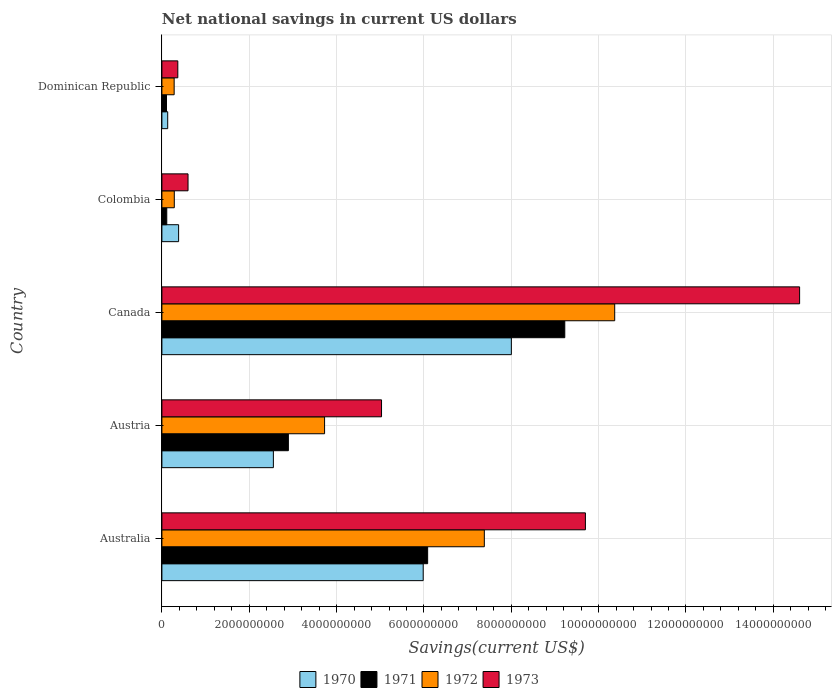How many different coloured bars are there?
Provide a short and direct response. 4. How many groups of bars are there?
Offer a very short reply. 5. Are the number of bars on each tick of the Y-axis equal?
Make the answer very short. Yes. How many bars are there on the 1st tick from the bottom?
Make the answer very short. 4. What is the net national savings in 1970 in Colombia?
Provide a short and direct response. 3.83e+08. Across all countries, what is the maximum net national savings in 1971?
Offer a terse response. 9.23e+09. Across all countries, what is the minimum net national savings in 1972?
Keep it short and to the point. 2.80e+08. In which country was the net national savings in 1971 minimum?
Your answer should be compact. Dominican Republic. What is the total net national savings in 1971 in the graph?
Offer a very short reply. 1.84e+1. What is the difference between the net national savings in 1971 in Austria and that in Dominican Republic?
Your response must be concise. 2.79e+09. What is the difference between the net national savings in 1970 in Australia and the net national savings in 1972 in Austria?
Give a very brief answer. 2.26e+09. What is the average net national savings in 1972 per country?
Keep it short and to the point. 4.41e+09. What is the difference between the net national savings in 1973 and net national savings in 1971 in Dominican Republic?
Offer a very short reply. 2.59e+08. In how many countries, is the net national savings in 1970 greater than 10000000000 US$?
Ensure brevity in your answer.  0. What is the ratio of the net national savings in 1973 in Canada to that in Dominican Republic?
Your answer should be compact. 40.06. Is the difference between the net national savings in 1973 in Austria and Canada greater than the difference between the net national savings in 1971 in Austria and Canada?
Provide a short and direct response. No. What is the difference between the highest and the second highest net national savings in 1970?
Give a very brief answer. 2.02e+09. What is the difference between the highest and the lowest net national savings in 1972?
Provide a short and direct response. 1.01e+1. Is the sum of the net national savings in 1972 in Colombia and Dominican Republic greater than the maximum net national savings in 1973 across all countries?
Your answer should be compact. No. Is it the case that in every country, the sum of the net national savings in 1973 and net national savings in 1971 is greater than the sum of net national savings in 1972 and net national savings in 1970?
Offer a terse response. No. What does the 3rd bar from the bottom in Colombia represents?
Provide a short and direct response. 1972. How many bars are there?
Give a very brief answer. 20. Are all the bars in the graph horizontal?
Provide a succinct answer. Yes. What is the difference between two consecutive major ticks on the X-axis?
Offer a terse response. 2.00e+09. Are the values on the major ticks of X-axis written in scientific E-notation?
Keep it short and to the point. No. Does the graph contain grids?
Ensure brevity in your answer.  Yes. Where does the legend appear in the graph?
Provide a succinct answer. Bottom center. How are the legend labels stacked?
Provide a short and direct response. Horizontal. What is the title of the graph?
Provide a short and direct response. Net national savings in current US dollars. What is the label or title of the X-axis?
Provide a succinct answer. Savings(current US$). What is the Savings(current US$) in 1970 in Australia?
Make the answer very short. 5.98e+09. What is the Savings(current US$) of 1971 in Australia?
Your answer should be compact. 6.09e+09. What is the Savings(current US$) of 1972 in Australia?
Your answer should be compact. 7.38e+09. What is the Savings(current US$) of 1973 in Australia?
Make the answer very short. 9.70e+09. What is the Savings(current US$) of 1970 in Austria?
Keep it short and to the point. 2.55e+09. What is the Savings(current US$) in 1971 in Austria?
Provide a short and direct response. 2.90e+09. What is the Savings(current US$) in 1972 in Austria?
Your answer should be very brief. 3.73e+09. What is the Savings(current US$) in 1973 in Austria?
Offer a very short reply. 5.03e+09. What is the Savings(current US$) of 1970 in Canada?
Your answer should be very brief. 8.00e+09. What is the Savings(current US$) of 1971 in Canada?
Make the answer very short. 9.23e+09. What is the Savings(current US$) in 1972 in Canada?
Your response must be concise. 1.04e+1. What is the Savings(current US$) of 1973 in Canada?
Offer a terse response. 1.46e+1. What is the Savings(current US$) in 1970 in Colombia?
Your answer should be compact. 3.83e+08. What is the Savings(current US$) in 1971 in Colombia?
Your answer should be compact. 1.11e+08. What is the Savings(current US$) in 1972 in Colombia?
Ensure brevity in your answer.  2.84e+08. What is the Savings(current US$) in 1973 in Colombia?
Offer a very short reply. 5.98e+08. What is the Savings(current US$) of 1970 in Dominican Republic?
Your answer should be very brief. 1.33e+08. What is the Savings(current US$) in 1971 in Dominican Republic?
Provide a short and direct response. 1.05e+08. What is the Savings(current US$) in 1972 in Dominican Republic?
Keep it short and to the point. 2.80e+08. What is the Savings(current US$) in 1973 in Dominican Republic?
Provide a succinct answer. 3.65e+08. Across all countries, what is the maximum Savings(current US$) of 1970?
Your answer should be very brief. 8.00e+09. Across all countries, what is the maximum Savings(current US$) of 1971?
Your answer should be compact. 9.23e+09. Across all countries, what is the maximum Savings(current US$) in 1972?
Offer a terse response. 1.04e+1. Across all countries, what is the maximum Savings(current US$) in 1973?
Keep it short and to the point. 1.46e+1. Across all countries, what is the minimum Savings(current US$) of 1970?
Give a very brief answer. 1.33e+08. Across all countries, what is the minimum Savings(current US$) of 1971?
Provide a short and direct response. 1.05e+08. Across all countries, what is the minimum Savings(current US$) of 1972?
Make the answer very short. 2.80e+08. Across all countries, what is the minimum Savings(current US$) in 1973?
Your answer should be very brief. 3.65e+08. What is the total Savings(current US$) of 1970 in the graph?
Make the answer very short. 1.71e+1. What is the total Savings(current US$) of 1971 in the graph?
Provide a succinct answer. 1.84e+1. What is the total Savings(current US$) of 1972 in the graph?
Your answer should be compact. 2.20e+1. What is the total Savings(current US$) of 1973 in the graph?
Provide a short and direct response. 3.03e+1. What is the difference between the Savings(current US$) of 1970 in Australia and that in Austria?
Offer a terse response. 3.43e+09. What is the difference between the Savings(current US$) of 1971 in Australia and that in Austria?
Ensure brevity in your answer.  3.19e+09. What is the difference between the Savings(current US$) in 1972 in Australia and that in Austria?
Offer a very short reply. 3.66e+09. What is the difference between the Savings(current US$) of 1973 in Australia and that in Austria?
Your answer should be very brief. 4.67e+09. What is the difference between the Savings(current US$) of 1970 in Australia and that in Canada?
Your answer should be very brief. -2.02e+09. What is the difference between the Savings(current US$) in 1971 in Australia and that in Canada?
Make the answer very short. -3.14e+09. What is the difference between the Savings(current US$) in 1972 in Australia and that in Canada?
Give a very brief answer. -2.99e+09. What is the difference between the Savings(current US$) in 1973 in Australia and that in Canada?
Give a very brief answer. -4.90e+09. What is the difference between the Savings(current US$) in 1970 in Australia and that in Colombia?
Offer a very short reply. 5.60e+09. What is the difference between the Savings(current US$) in 1971 in Australia and that in Colombia?
Your answer should be compact. 5.97e+09. What is the difference between the Savings(current US$) of 1972 in Australia and that in Colombia?
Your response must be concise. 7.10e+09. What is the difference between the Savings(current US$) in 1973 in Australia and that in Colombia?
Your response must be concise. 9.10e+09. What is the difference between the Savings(current US$) of 1970 in Australia and that in Dominican Republic?
Ensure brevity in your answer.  5.85e+09. What is the difference between the Savings(current US$) of 1971 in Australia and that in Dominican Republic?
Offer a very short reply. 5.98e+09. What is the difference between the Savings(current US$) in 1972 in Australia and that in Dominican Republic?
Your answer should be compact. 7.10e+09. What is the difference between the Savings(current US$) in 1973 in Australia and that in Dominican Republic?
Offer a terse response. 9.33e+09. What is the difference between the Savings(current US$) of 1970 in Austria and that in Canada?
Your response must be concise. -5.45e+09. What is the difference between the Savings(current US$) of 1971 in Austria and that in Canada?
Provide a short and direct response. -6.33e+09. What is the difference between the Savings(current US$) in 1972 in Austria and that in Canada?
Offer a terse response. -6.64e+09. What is the difference between the Savings(current US$) of 1973 in Austria and that in Canada?
Ensure brevity in your answer.  -9.57e+09. What is the difference between the Savings(current US$) of 1970 in Austria and that in Colombia?
Your answer should be compact. 2.17e+09. What is the difference between the Savings(current US$) in 1971 in Austria and that in Colombia?
Provide a succinct answer. 2.78e+09. What is the difference between the Savings(current US$) of 1972 in Austria and that in Colombia?
Offer a terse response. 3.44e+09. What is the difference between the Savings(current US$) of 1973 in Austria and that in Colombia?
Your answer should be compact. 4.43e+09. What is the difference between the Savings(current US$) of 1970 in Austria and that in Dominican Republic?
Your response must be concise. 2.42e+09. What is the difference between the Savings(current US$) of 1971 in Austria and that in Dominican Republic?
Provide a short and direct response. 2.79e+09. What is the difference between the Savings(current US$) of 1972 in Austria and that in Dominican Republic?
Your answer should be very brief. 3.44e+09. What is the difference between the Savings(current US$) of 1973 in Austria and that in Dominican Republic?
Keep it short and to the point. 4.66e+09. What is the difference between the Savings(current US$) in 1970 in Canada and that in Colombia?
Offer a terse response. 7.62e+09. What is the difference between the Savings(current US$) of 1971 in Canada and that in Colombia?
Your response must be concise. 9.11e+09. What is the difference between the Savings(current US$) in 1972 in Canada and that in Colombia?
Offer a very short reply. 1.01e+1. What is the difference between the Savings(current US$) of 1973 in Canada and that in Colombia?
Your answer should be very brief. 1.40e+1. What is the difference between the Savings(current US$) in 1970 in Canada and that in Dominican Republic?
Your answer should be compact. 7.87e+09. What is the difference between the Savings(current US$) in 1971 in Canada and that in Dominican Republic?
Provide a short and direct response. 9.12e+09. What is the difference between the Savings(current US$) of 1972 in Canada and that in Dominican Republic?
Your answer should be very brief. 1.01e+1. What is the difference between the Savings(current US$) in 1973 in Canada and that in Dominican Republic?
Your answer should be compact. 1.42e+1. What is the difference between the Savings(current US$) in 1970 in Colombia and that in Dominican Republic?
Offer a terse response. 2.50e+08. What is the difference between the Savings(current US$) of 1971 in Colombia and that in Dominican Republic?
Your answer should be very brief. 6.03e+06. What is the difference between the Savings(current US$) of 1972 in Colombia and that in Dominican Republic?
Your answer should be very brief. 3.48e+06. What is the difference between the Savings(current US$) in 1973 in Colombia and that in Dominican Republic?
Offer a very short reply. 2.34e+08. What is the difference between the Savings(current US$) of 1970 in Australia and the Savings(current US$) of 1971 in Austria?
Provide a succinct answer. 3.09e+09. What is the difference between the Savings(current US$) in 1970 in Australia and the Savings(current US$) in 1972 in Austria?
Provide a short and direct response. 2.26e+09. What is the difference between the Savings(current US$) of 1970 in Australia and the Savings(current US$) of 1973 in Austria?
Provide a succinct answer. 9.54e+08. What is the difference between the Savings(current US$) of 1971 in Australia and the Savings(current US$) of 1972 in Austria?
Your answer should be compact. 2.36e+09. What is the difference between the Savings(current US$) in 1971 in Australia and the Savings(current US$) in 1973 in Austria?
Ensure brevity in your answer.  1.06e+09. What is the difference between the Savings(current US$) of 1972 in Australia and the Savings(current US$) of 1973 in Austria?
Keep it short and to the point. 2.35e+09. What is the difference between the Savings(current US$) of 1970 in Australia and the Savings(current US$) of 1971 in Canada?
Your response must be concise. -3.24e+09. What is the difference between the Savings(current US$) in 1970 in Australia and the Savings(current US$) in 1972 in Canada?
Keep it short and to the point. -4.38e+09. What is the difference between the Savings(current US$) of 1970 in Australia and the Savings(current US$) of 1973 in Canada?
Provide a succinct answer. -8.62e+09. What is the difference between the Savings(current US$) of 1971 in Australia and the Savings(current US$) of 1972 in Canada?
Your response must be concise. -4.28e+09. What is the difference between the Savings(current US$) in 1971 in Australia and the Savings(current US$) in 1973 in Canada?
Provide a succinct answer. -8.52e+09. What is the difference between the Savings(current US$) in 1972 in Australia and the Savings(current US$) in 1973 in Canada?
Provide a succinct answer. -7.22e+09. What is the difference between the Savings(current US$) of 1970 in Australia and the Savings(current US$) of 1971 in Colombia?
Give a very brief answer. 5.87e+09. What is the difference between the Savings(current US$) in 1970 in Australia and the Savings(current US$) in 1972 in Colombia?
Your response must be concise. 5.70e+09. What is the difference between the Savings(current US$) of 1970 in Australia and the Savings(current US$) of 1973 in Colombia?
Keep it short and to the point. 5.38e+09. What is the difference between the Savings(current US$) of 1971 in Australia and the Savings(current US$) of 1972 in Colombia?
Provide a succinct answer. 5.80e+09. What is the difference between the Savings(current US$) of 1971 in Australia and the Savings(current US$) of 1973 in Colombia?
Offer a very short reply. 5.49e+09. What is the difference between the Savings(current US$) in 1972 in Australia and the Savings(current US$) in 1973 in Colombia?
Make the answer very short. 6.78e+09. What is the difference between the Savings(current US$) in 1970 in Australia and the Savings(current US$) in 1971 in Dominican Republic?
Provide a succinct answer. 5.88e+09. What is the difference between the Savings(current US$) in 1970 in Australia and the Savings(current US$) in 1972 in Dominican Republic?
Ensure brevity in your answer.  5.70e+09. What is the difference between the Savings(current US$) of 1970 in Australia and the Savings(current US$) of 1973 in Dominican Republic?
Offer a very short reply. 5.62e+09. What is the difference between the Savings(current US$) of 1971 in Australia and the Savings(current US$) of 1972 in Dominican Republic?
Provide a succinct answer. 5.80e+09. What is the difference between the Savings(current US$) in 1971 in Australia and the Savings(current US$) in 1973 in Dominican Republic?
Give a very brief answer. 5.72e+09. What is the difference between the Savings(current US$) in 1972 in Australia and the Savings(current US$) in 1973 in Dominican Republic?
Ensure brevity in your answer.  7.02e+09. What is the difference between the Savings(current US$) in 1970 in Austria and the Savings(current US$) in 1971 in Canada?
Ensure brevity in your answer.  -6.67e+09. What is the difference between the Savings(current US$) of 1970 in Austria and the Savings(current US$) of 1972 in Canada?
Make the answer very short. -7.82e+09. What is the difference between the Savings(current US$) in 1970 in Austria and the Savings(current US$) in 1973 in Canada?
Your answer should be very brief. -1.20e+1. What is the difference between the Savings(current US$) of 1971 in Austria and the Savings(current US$) of 1972 in Canada?
Your answer should be compact. -7.47e+09. What is the difference between the Savings(current US$) in 1971 in Austria and the Savings(current US$) in 1973 in Canada?
Your answer should be very brief. -1.17e+1. What is the difference between the Savings(current US$) of 1972 in Austria and the Savings(current US$) of 1973 in Canada?
Your response must be concise. -1.09e+1. What is the difference between the Savings(current US$) of 1970 in Austria and the Savings(current US$) of 1971 in Colombia?
Give a very brief answer. 2.44e+09. What is the difference between the Savings(current US$) in 1970 in Austria and the Savings(current US$) in 1972 in Colombia?
Ensure brevity in your answer.  2.27e+09. What is the difference between the Savings(current US$) of 1970 in Austria and the Savings(current US$) of 1973 in Colombia?
Provide a succinct answer. 1.95e+09. What is the difference between the Savings(current US$) of 1971 in Austria and the Savings(current US$) of 1972 in Colombia?
Your response must be concise. 2.61e+09. What is the difference between the Savings(current US$) in 1971 in Austria and the Savings(current US$) in 1973 in Colombia?
Your response must be concise. 2.30e+09. What is the difference between the Savings(current US$) in 1972 in Austria and the Savings(current US$) in 1973 in Colombia?
Offer a very short reply. 3.13e+09. What is the difference between the Savings(current US$) in 1970 in Austria and the Savings(current US$) in 1971 in Dominican Republic?
Ensure brevity in your answer.  2.45e+09. What is the difference between the Savings(current US$) in 1970 in Austria and the Savings(current US$) in 1972 in Dominican Republic?
Your answer should be compact. 2.27e+09. What is the difference between the Savings(current US$) in 1970 in Austria and the Savings(current US$) in 1973 in Dominican Republic?
Provide a short and direct response. 2.19e+09. What is the difference between the Savings(current US$) in 1971 in Austria and the Savings(current US$) in 1972 in Dominican Republic?
Provide a succinct answer. 2.62e+09. What is the difference between the Savings(current US$) of 1971 in Austria and the Savings(current US$) of 1973 in Dominican Republic?
Provide a succinct answer. 2.53e+09. What is the difference between the Savings(current US$) in 1972 in Austria and the Savings(current US$) in 1973 in Dominican Republic?
Provide a succinct answer. 3.36e+09. What is the difference between the Savings(current US$) of 1970 in Canada and the Savings(current US$) of 1971 in Colombia?
Offer a very short reply. 7.89e+09. What is the difference between the Savings(current US$) of 1970 in Canada and the Savings(current US$) of 1972 in Colombia?
Give a very brief answer. 7.72e+09. What is the difference between the Savings(current US$) of 1970 in Canada and the Savings(current US$) of 1973 in Colombia?
Make the answer very short. 7.40e+09. What is the difference between the Savings(current US$) of 1971 in Canada and the Savings(current US$) of 1972 in Colombia?
Your answer should be compact. 8.94e+09. What is the difference between the Savings(current US$) of 1971 in Canada and the Savings(current US$) of 1973 in Colombia?
Your response must be concise. 8.63e+09. What is the difference between the Savings(current US$) in 1972 in Canada and the Savings(current US$) in 1973 in Colombia?
Make the answer very short. 9.77e+09. What is the difference between the Savings(current US$) of 1970 in Canada and the Savings(current US$) of 1971 in Dominican Republic?
Your response must be concise. 7.90e+09. What is the difference between the Savings(current US$) of 1970 in Canada and the Savings(current US$) of 1972 in Dominican Republic?
Provide a succinct answer. 7.72e+09. What is the difference between the Savings(current US$) of 1970 in Canada and the Savings(current US$) of 1973 in Dominican Republic?
Your answer should be compact. 7.64e+09. What is the difference between the Savings(current US$) in 1971 in Canada and the Savings(current US$) in 1972 in Dominican Republic?
Provide a short and direct response. 8.94e+09. What is the difference between the Savings(current US$) of 1971 in Canada and the Savings(current US$) of 1973 in Dominican Republic?
Give a very brief answer. 8.86e+09. What is the difference between the Savings(current US$) in 1972 in Canada and the Savings(current US$) in 1973 in Dominican Republic?
Provide a succinct answer. 1.00e+1. What is the difference between the Savings(current US$) in 1970 in Colombia and the Savings(current US$) in 1971 in Dominican Republic?
Give a very brief answer. 2.77e+08. What is the difference between the Savings(current US$) of 1970 in Colombia and the Savings(current US$) of 1972 in Dominican Republic?
Keep it short and to the point. 1.02e+08. What is the difference between the Savings(current US$) of 1970 in Colombia and the Savings(current US$) of 1973 in Dominican Republic?
Ensure brevity in your answer.  1.82e+07. What is the difference between the Savings(current US$) of 1971 in Colombia and the Savings(current US$) of 1972 in Dominican Republic?
Your response must be concise. -1.69e+08. What is the difference between the Savings(current US$) of 1971 in Colombia and the Savings(current US$) of 1973 in Dominican Republic?
Your response must be concise. -2.53e+08. What is the difference between the Savings(current US$) in 1972 in Colombia and the Savings(current US$) in 1973 in Dominican Republic?
Offer a terse response. -8.05e+07. What is the average Savings(current US$) in 1970 per country?
Ensure brevity in your answer.  3.41e+09. What is the average Savings(current US$) of 1971 per country?
Keep it short and to the point. 3.68e+09. What is the average Savings(current US$) in 1972 per country?
Your response must be concise. 4.41e+09. What is the average Savings(current US$) in 1973 per country?
Keep it short and to the point. 6.06e+09. What is the difference between the Savings(current US$) in 1970 and Savings(current US$) in 1971 in Australia?
Ensure brevity in your answer.  -1.02e+08. What is the difference between the Savings(current US$) in 1970 and Savings(current US$) in 1972 in Australia?
Your answer should be very brief. -1.40e+09. What is the difference between the Savings(current US$) of 1970 and Savings(current US$) of 1973 in Australia?
Offer a terse response. -3.71e+09. What is the difference between the Savings(current US$) of 1971 and Savings(current US$) of 1972 in Australia?
Your response must be concise. -1.30e+09. What is the difference between the Savings(current US$) of 1971 and Savings(current US$) of 1973 in Australia?
Offer a very short reply. -3.61e+09. What is the difference between the Savings(current US$) of 1972 and Savings(current US$) of 1973 in Australia?
Ensure brevity in your answer.  -2.31e+09. What is the difference between the Savings(current US$) of 1970 and Savings(current US$) of 1971 in Austria?
Your answer should be compact. -3.44e+08. What is the difference between the Savings(current US$) of 1970 and Savings(current US$) of 1972 in Austria?
Keep it short and to the point. -1.17e+09. What is the difference between the Savings(current US$) in 1970 and Savings(current US$) in 1973 in Austria?
Offer a terse response. -2.48e+09. What is the difference between the Savings(current US$) of 1971 and Savings(current US$) of 1972 in Austria?
Your answer should be very brief. -8.29e+08. What is the difference between the Savings(current US$) in 1971 and Savings(current US$) in 1973 in Austria?
Your answer should be compact. -2.13e+09. What is the difference between the Savings(current US$) of 1972 and Savings(current US$) of 1973 in Austria?
Your response must be concise. -1.30e+09. What is the difference between the Savings(current US$) of 1970 and Savings(current US$) of 1971 in Canada?
Provide a succinct answer. -1.22e+09. What is the difference between the Savings(current US$) of 1970 and Savings(current US$) of 1972 in Canada?
Ensure brevity in your answer.  -2.37e+09. What is the difference between the Savings(current US$) of 1970 and Savings(current US$) of 1973 in Canada?
Provide a short and direct response. -6.60e+09. What is the difference between the Savings(current US$) in 1971 and Savings(current US$) in 1972 in Canada?
Your answer should be compact. -1.14e+09. What is the difference between the Savings(current US$) of 1971 and Savings(current US$) of 1973 in Canada?
Offer a terse response. -5.38e+09. What is the difference between the Savings(current US$) in 1972 and Savings(current US$) in 1973 in Canada?
Your answer should be very brief. -4.23e+09. What is the difference between the Savings(current US$) in 1970 and Savings(current US$) in 1971 in Colombia?
Provide a succinct answer. 2.71e+08. What is the difference between the Savings(current US$) of 1970 and Savings(current US$) of 1972 in Colombia?
Your response must be concise. 9.87e+07. What is the difference between the Savings(current US$) in 1970 and Savings(current US$) in 1973 in Colombia?
Offer a very short reply. -2.16e+08. What is the difference between the Savings(current US$) of 1971 and Savings(current US$) of 1972 in Colombia?
Keep it short and to the point. -1.73e+08. What is the difference between the Savings(current US$) of 1971 and Savings(current US$) of 1973 in Colombia?
Your response must be concise. -4.87e+08. What is the difference between the Savings(current US$) of 1972 and Savings(current US$) of 1973 in Colombia?
Make the answer very short. -3.14e+08. What is the difference between the Savings(current US$) in 1970 and Savings(current US$) in 1971 in Dominican Republic?
Keep it short and to the point. 2.74e+07. What is the difference between the Savings(current US$) of 1970 and Savings(current US$) of 1972 in Dominican Republic?
Offer a terse response. -1.48e+08. What is the difference between the Savings(current US$) in 1970 and Savings(current US$) in 1973 in Dominican Republic?
Provide a succinct answer. -2.32e+08. What is the difference between the Savings(current US$) in 1971 and Savings(current US$) in 1972 in Dominican Republic?
Provide a short and direct response. -1.75e+08. What is the difference between the Savings(current US$) of 1971 and Savings(current US$) of 1973 in Dominican Republic?
Your response must be concise. -2.59e+08. What is the difference between the Savings(current US$) in 1972 and Savings(current US$) in 1973 in Dominican Republic?
Keep it short and to the point. -8.40e+07. What is the ratio of the Savings(current US$) in 1970 in Australia to that in Austria?
Keep it short and to the point. 2.34. What is the ratio of the Savings(current US$) in 1971 in Australia to that in Austria?
Provide a short and direct response. 2.1. What is the ratio of the Savings(current US$) of 1972 in Australia to that in Austria?
Your answer should be very brief. 1.98. What is the ratio of the Savings(current US$) of 1973 in Australia to that in Austria?
Provide a succinct answer. 1.93. What is the ratio of the Savings(current US$) of 1970 in Australia to that in Canada?
Offer a very short reply. 0.75. What is the ratio of the Savings(current US$) in 1971 in Australia to that in Canada?
Offer a very short reply. 0.66. What is the ratio of the Savings(current US$) of 1972 in Australia to that in Canada?
Ensure brevity in your answer.  0.71. What is the ratio of the Savings(current US$) in 1973 in Australia to that in Canada?
Make the answer very short. 0.66. What is the ratio of the Savings(current US$) in 1970 in Australia to that in Colombia?
Your answer should be compact. 15.64. What is the ratio of the Savings(current US$) of 1971 in Australia to that in Colombia?
Your response must be concise. 54.61. What is the ratio of the Savings(current US$) of 1972 in Australia to that in Colombia?
Your response must be concise. 26. What is the ratio of the Savings(current US$) in 1973 in Australia to that in Colombia?
Offer a very short reply. 16.2. What is the ratio of the Savings(current US$) in 1970 in Australia to that in Dominican Republic?
Keep it short and to the point. 45.07. What is the ratio of the Savings(current US$) of 1971 in Australia to that in Dominican Republic?
Keep it short and to the point. 57.73. What is the ratio of the Savings(current US$) of 1972 in Australia to that in Dominican Republic?
Make the answer very short. 26.32. What is the ratio of the Savings(current US$) in 1973 in Australia to that in Dominican Republic?
Ensure brevity in your answer.  26.6. What is the ratio of the Savings(current US$) in 1970 in Austria to that in Canada?
Offer a very short reply. 0.32. What is the ratio of the Savings(current US$) in 1971 in Austria to that in Canada?
Keep it short and to the point. 0.31. What is the ratio of the Savings(current US$) in 1972 in Austria to that in Canada?
Keep it short and to the point. 0.36. What is the ratio of the Savings(current US$) of 1973 in Austria to that in Canada?
Your answer should be compact. 0.34. What is the ratio of the Savings(current US$) in 1970 in Austria to that in Colombia?
Your answer should be very brief. 6.67. What is the ratio of the Savings(current US$) of 1971 in Austria to that in Colombia?
Keep it short and to the point. 25.99. What is the ratio of the Savings(current US$) in 1972 in Austria to that in Colombia?
Give a very brief answer. 13.12. What is the ratio of the Savings(current US$) of 1973 in Austria to that in Colombia?
Provide a short and direct response. 8.4. What is the ratio of the Savings(current US$) of 1970 in Austria to that in Dominican Republic?
Offer a very short reply. 19.23. What is the ratio of the Savings(current US$) of 1971 in Austria to that in Dominican Republic?
Your answer should be very brief. 27.48. What is the ratio of the Savings(current US$) in 1972 in Austria to that in Dominican Republic?
Provide a short and direct response. 13.28. What is the ratio of the Savings(current US$) of 1973 in Austria to that in Dominican Republic?
Your answer should be very brief. 13.8. What is the ratio of the Savings(current US$) of 1970 in Canada to that in Colombia?
Provide a succinct answer. 20.91. What is the ratio of the Savings(current US$) in 1971 in Canada to that in Colombia?
Provide a succinct answer. 82.79. What is the ratio of the Savings(current US$) of 1972 in Canada to that in Colombia?
Offer a very short reply. 36.51. What is the ratio of the Savings(current US$) in 1973 in Canada to that in Colombia?
Your answer should be compact. 24.4. What is the ratio of the Savings(current US$) of 1970 in Canada to that in Dominican Republic?
Your answer should be very brief. 60.27. What is the ratio of the Savings(current US$) of 1971 in Canada to that in Dominican Republic?
Offer a very short reply. 87.52. What is the ratio of the Savings(current US$) of 1972 in Canada to that in Dominican Republic?
Offer a very short reply. 36.96. What is the ratio of the Savings(current US$) in 1973 in Canada to that in Dominican Republic?
Your response must be concise. 40.06. What is the ratio of the Savings(current US$) of 1970 in Colombia to that in Dominican Republic?
Offer a very short reply. 2.88. What is the ratio of the Savings(current US$) in 1971 in Colombia to that in Dominican Republic?
Your answer should be very brief. 1.06. What is the ratio of the Savings(current US$) of 1972 in Colombia to that in Dominican Republic?
Your answer should be very brief. 1.01. What is the ratio of the Savings(current US$) in 1973 in Colombia to that in Dominican Republic?
Your response must be concise. 1.64. What is the difference between the highest and the second highest Savings(current US$) of 1970?
Offer a very short reply. 2.02e+09. What is the difference between the highest and the second highest Savings(current US$) of 1971?
Offer a very short reply. 3.14e+09. What is the difference between the highest and the second highest Savings(current US$) in 1972?
Offer a very short reply. 2.99e+09. What is the difference between the highest and the second highest Savings(current US$) of 1973?
Give a very brief answer. 4.90e+09. What is the difference between the highest and the lowest Savings(current US$) of 1970?
Your answer should be compact. 7.87e+09. What is the difference between the highest and the lowest Savings(current US$) in 1971?
Ensure brevity in your answer.  9.12e+09. What is the difference between the highest and the lowest Savings(current US$) in 1972?
Ensure brevity in your answer.  1.01e+1. What is the difference between the highest and the lowest Savings(current US$) of 1973?
Keep it short and to the point. 1.42e+1. 